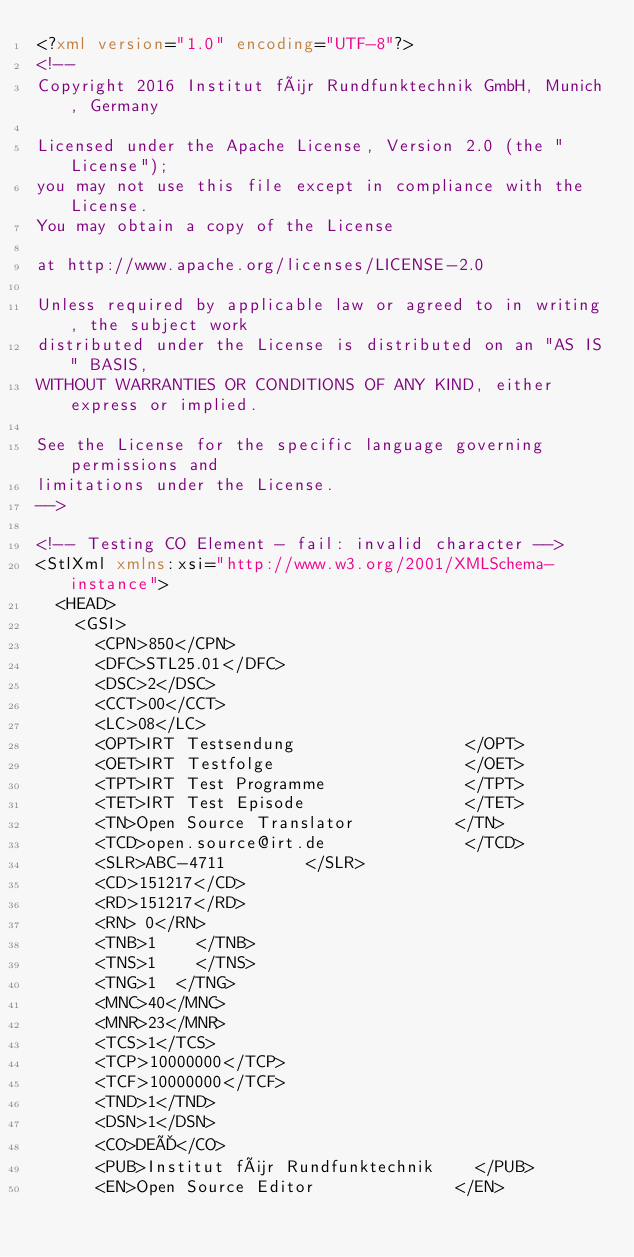Convert code to text. <code><loc_0><loc_0><loc_500><loc_500><_XML_><?xml version="1.0" encoding="UTF-8"?>
<!--
Copyright 2016 Institut für Rundfunktechnik GmbH, Munich, Germany

Licensed under the Apache License, Version 2.0 (the "License"); 
you may not use this file except in compliance with the License.
You may obtain a copy of the License 

at http://www.apache.org/licenses/LICENSE-2.0

Unless required by applicable law or agreed to in writing, the subject work
distributed under the License is distributed on an "AS IS" BASIS,
WITHOUT WARRANTIES OR CONDITIONS OF ANY KIND, either express or implied.

See the License for the specific language governing permissions and
limitations under the License.
-->

<!-- Testing CO Element - fail: invalid character -->
<StlXml xmlns:xsi="http://www.w3.org/2001/XMLSchema-instance">
  <HEAD>
    <GSI>
      <CPN>850</CPN>
      <DFC>STL25.01</DFC>
      <DSC>2</DSC>
      <CCT>00</CCT>
      <LC>08</LC>
      <OPT>IRT Testsendung                 </OPT>
      <OET>IRT Testfolge                   </OET>
      <TPT>IRT Test Programme              </TPT>
      <TET>IRT Test Episode                </TET>
      <TN>Open Source Translator          </TN>
      <TCD>open.source@irt.de              </TCD>
      <SLR>ABC-4711        </SLR>
      <CD>151217</CD>
      <RD>151217</RD>
      <RN> 0</RN>
      <TNB>1    </TNB>
      <TNS>1    </TNS>
      <TNG>1  </TNG>
      <MNC>40</MNC>
      <MNR>23</MNR>
      <TCS>1</TCS>
      <TCP>10000000</TCP>
      <TCF>10000000</TCF>
      <TND>1</TND>
      <DSN>1</DSN>
      <CO>DEÄ</CO>
      <PUB>Institut für Rundfunktechnik    </PUB>
      <EN>Open Source Editor              </EN></code> 